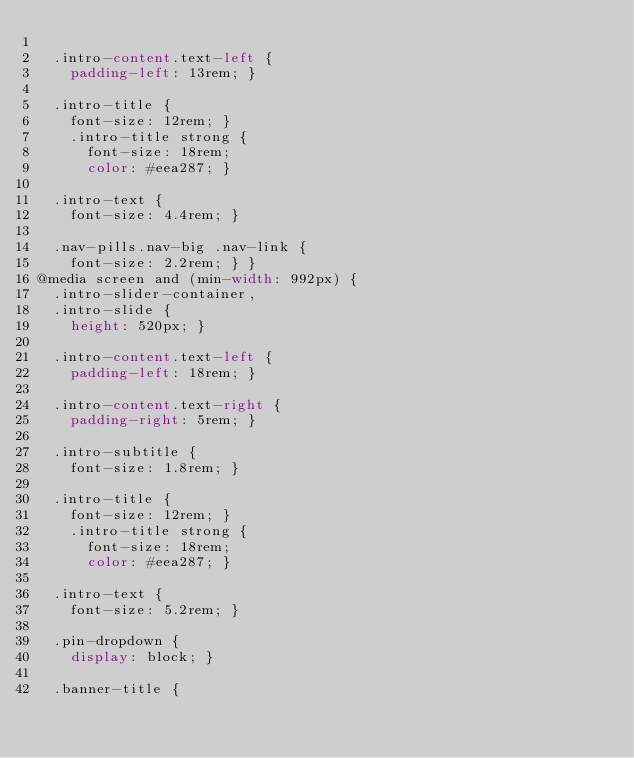<code> <loc_0><loc_0><loc_500><loc_500><_CSS_>
  .intro-content.text-left {
    padding-left: 13rem; }

  .intro-title {
    font-size: 12rem; }
    .intro-title strong {
      font-size: 18rem;
      color: #eea287; }

  .intro-text {
    font-size: 4.4rem; }

  .nav-pills.nav-big .nav-link {
    font-size: 2.2rem; } }
@media screen and (min-width: 992px) {
  .intro-slider-container,
  .intro-slide {
    height: 520px; }

  .intro-content.text-left {
    padding-left: 18rem; }

  .intro-content.text-right {
    padding-right: 5rem; }

  .intro-subtitle {
    font-size: 1.8rem; }

  .intro-title {
    font-size: 12rem; }
    .intro-title strong {
      font-size: 18rem;
      color: #eea287; }

  .intro-text {
    font-size: 5.2rem; }

  .pin-dropdown {
    display: block; }

  .banner-title {</code> 